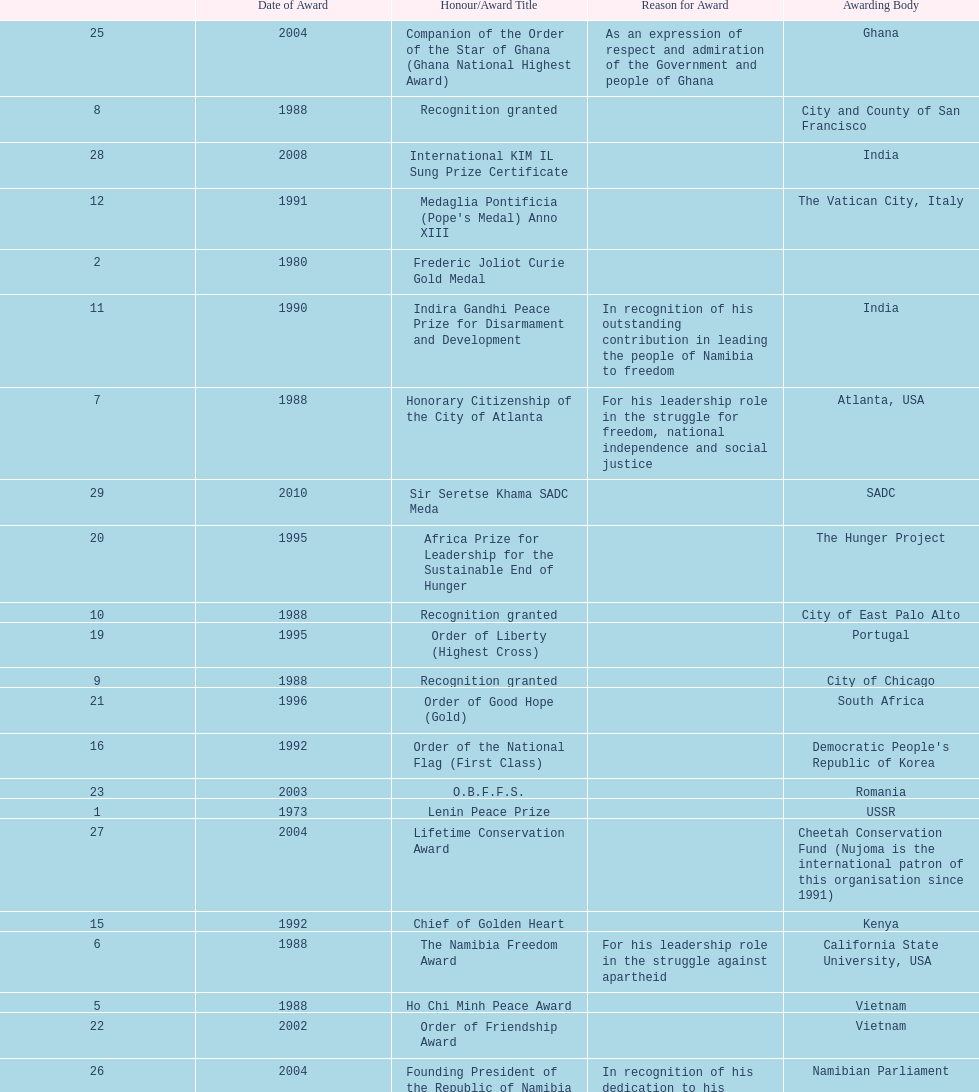What is the difference between the number of awards won in 1988 and the number of awards won in 1995? 4. 